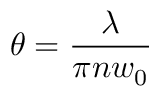Convert formula to latex. <formula><loc_0><loc_0><loc_500><loc_500>\theta = { \frac { \lambda } { \pi n w _ { 0 } } }</formula> 